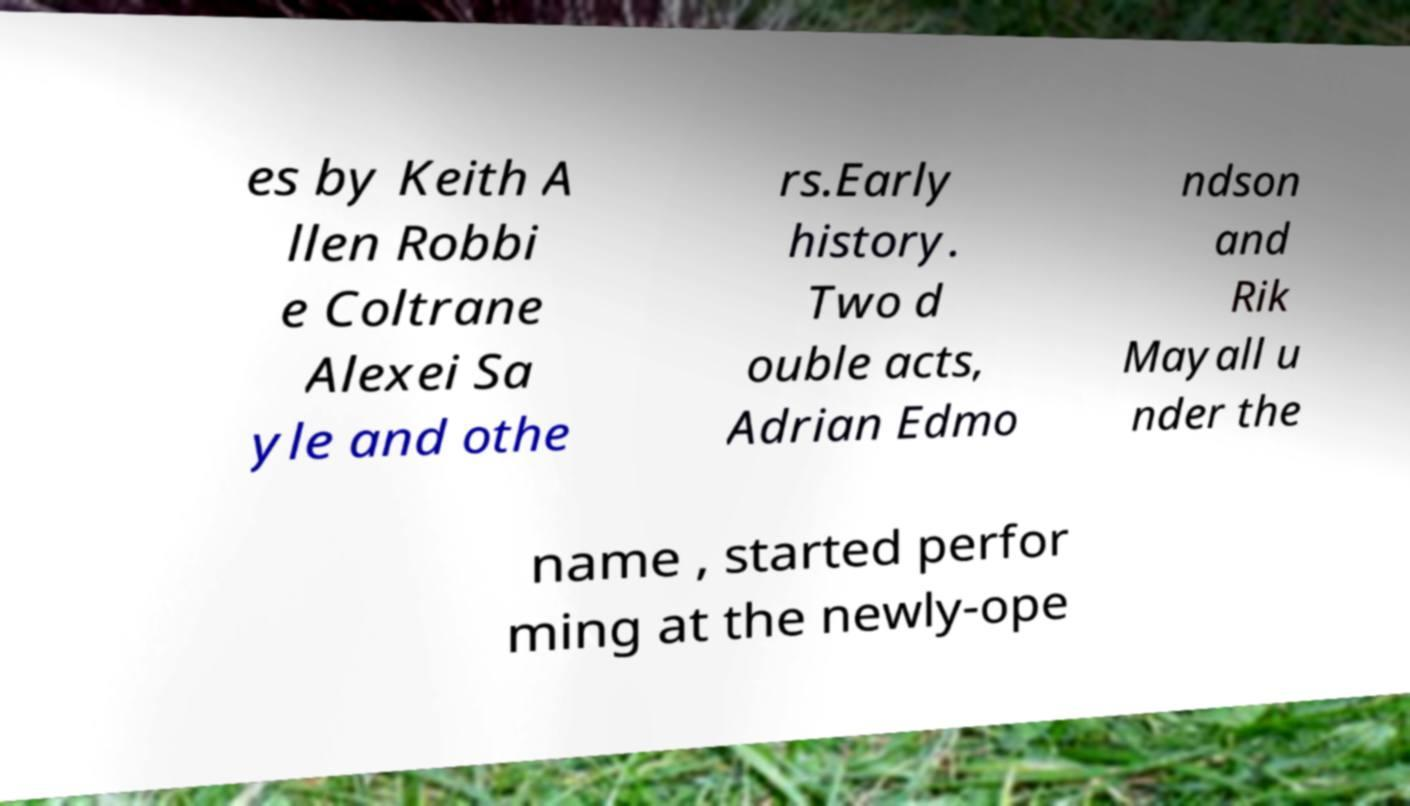What messages or text are displayed in this image? I need them in a readable, typed format. es by Keith A llen Robbi e Coltrane Alexei Sa yle and othe rs.Early history. Two d ouble acts, Adrian Edmo ndson and Rik Mayall u nder the name , started perfor ming at the newly-ope 